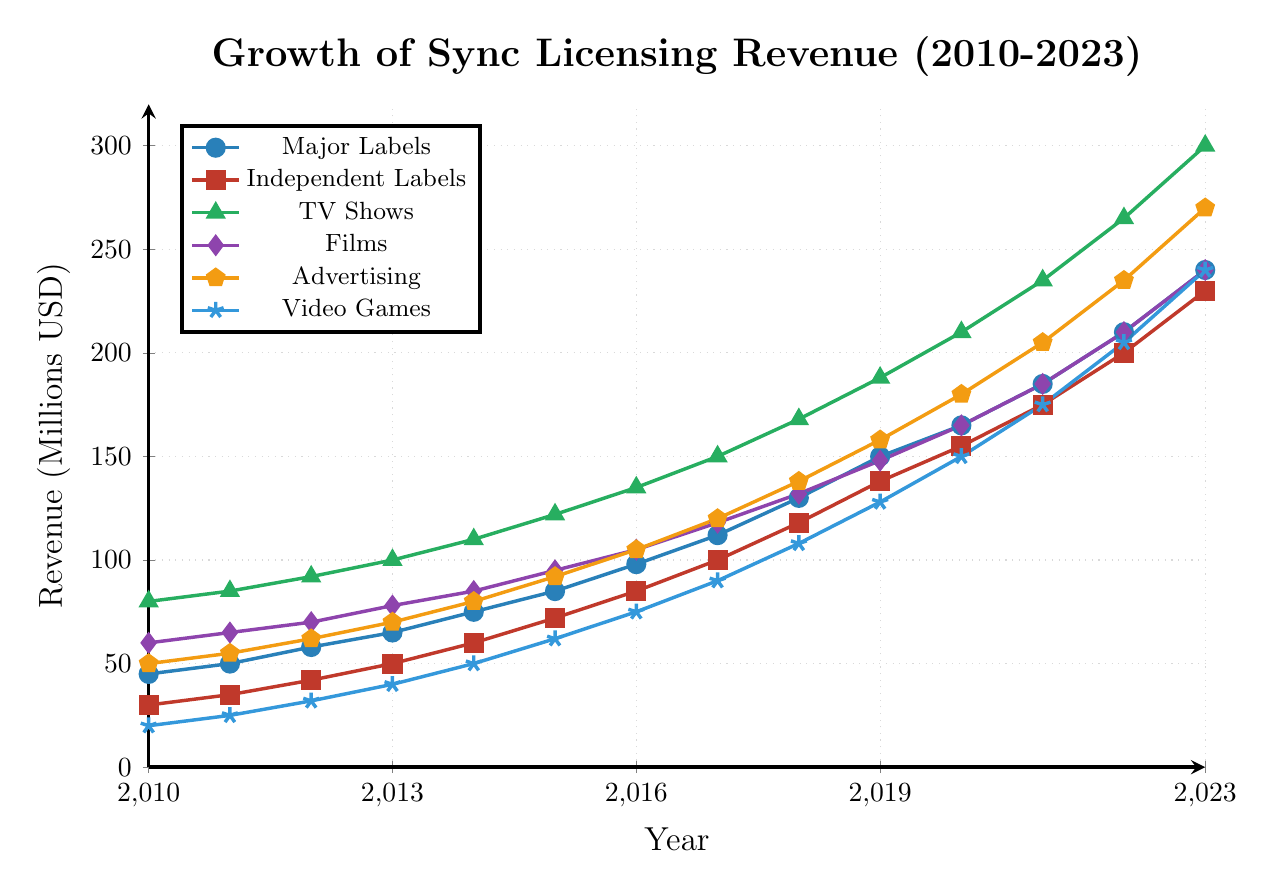What is the difference in revenue between Major Labels and Independent Labels in 2021? To find the difference in revenue between Major Labels and Independent Labels in 2021, locate their values in 2021 on the figure. For Major Labels, the revenue is 185 million USD, and for Independent Labels, it is 175 million USD. Subtract the revenue of Independent Labels from Major Labels: 185 - 175 = 10 million USD.
Answer: 10 million USD Which category had the highest revenue in 2016, and what was the value? Identify the revenues across all categories in 2016 from the figure. TV Shows had the highest revenue in 2016 with 135 million USD.
Answer: TV Shows, 135 million USD What was the average revenue for Films from 2010 to 2015? Calculate the average by summing up the revenue values for Films from 2010 to 2015: 60 + 65 + 70 + 78 + 85 + 95 = 453. Then, divide by the number of years, which is 6: 453 / 6 = 75.5 million USD.
Answer: 75.5 million USD In which year did Video Games revenue surpass the 100 million USD mark? Look at the values for Video Games each year until it exceeds 100 million USD. The revenue for Video Games surpassed 100 million USD in 2018, with a value of 108 million USD.
Answer: 2018 By how much did the revenue from Films increase from 2020 to 2023? Locate the revenue values for Films for 2020 and 2023. For 2020, the revenue is 165 million USD, and for 2023, it is 240 million USD. Subtract the 2020 value from the 2023 value: 240 - 165 = 75 million USD.
Answer: 75 million USD How many years did it take for Independent Labels revenue to reach 100 million USD starting from 2010? Find the first year where Independent Labels revenue is greater than or equal to 100 million USD, starting from 2010. It reached 100 million USD in 2017. From 2010 to 2017 is a span of 7 years.
Answer: 7 years What was the overall trend for TV Shows revenue from 2010 to 2023? Analyze the values from 2010 to 2023 for TV Shows. The revenue shows a consistent increase each year from 80 million USD in 2010 to 300 million USD in 2023.
Answer: Consistently increasing How did the revenue for Major Labels change from 2010 to 2018? Identify the revenue values for Major Labels in 2010 and 2018. For 2010, the revenue is 45 million USD, and for 2018, it is 130 million USD. The revenue increased by 130 - 45 = 85 million USD over this period.
Answer: Increased by 85 million USD Which category showed the second-largest revenue in 2023, and what was the value? Examine the revenue values for each category in 2023. TV Shows had the largest revenue (300 million USD), and the second-largest revenue was for Advertising with 270 million USD.
Answer: Advertising, 270 million USD 